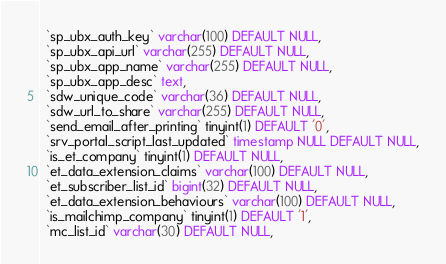<code> <loc_0><loc_0><loc_500><loc_500><_SQL_>  `sp_ubx_auth_key` varchar(100) DEFAULT NULL,
  `sp_ubx_api_url` varchar(255) DEFAULT NULL,
  `sp_ubx_app_name` varchar(255) DEFAULT NULL,
  `sp_ubx_app_desc` text,
  `sdw_unique_code` varchar(36) DEFAULT NULL,
  `sdw_url_to_share` varchar(255) DEFAULT NULL,
  `send_email_after_printing` tinyint(1) DEFAULT '0',
  `srv_portal_script_last_updated` timestamp NULL DEFAULT NULL,
  `is_et_company` tinyint(1) DEFAULT NULL,
  `et_data_extension_claims` varchar(100) DEFAULT NULL,
  `et_subscriber_list_id` bigint(32) DEFAULT NULL,
  `et_data_extension_behaviours` varchar(100) DEFAULT NULL,
  `is_mailchimp_company` tinyint(1) DEFAULT '1',
  `mc_list_id` varchar(30) DEFAULT NULL,</code> 